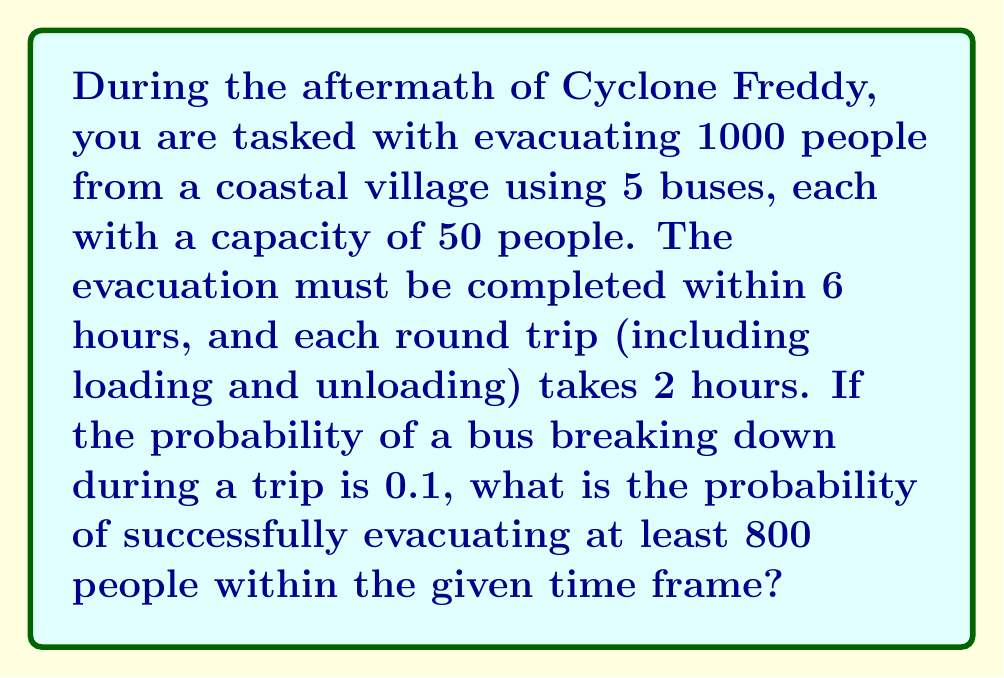Can you answer this question? Let's approach this problem step-by-step:

1) First, calculate the maximum number of trips possible in 6 hours:
   $\text{Maximum trips} = \frac{6 \text{ hours}}{2 \text{ hours per trip}} = 3 \text{ trips}$

2) Calculate the total capacity for all buses over 3 trips:
   $\text{Total capacity} = 5 \text{ buses} \times 50 \text{ people} \times 3 \text{ trips} = 750 \text{ people}$

3) To evacuate at least 800 people, we need all buses to make all 3 trips successfully, plus at least 1 additional trip from any bus.

4) Probability of a bus not breaking down on a single trip: $1 - 0.1 = 0.9$

5) Probability of a bus completing all 3 trips successfully: $0.9^3 = 0.729$

6) Probability of all 5 buses completing all 3 trips successfully:
   $0.729^5 \approx 0.1889$

7) For the additional trip, we need at least one bus to make an extra successful trip. Probability of at least one bus not breaking down:
   $1 - (0.1)^5 = 0.99999$

8) The final probability is the product of steps 6 and 7:
   $P(\text{success}) = 0.1889 \times 0.99999 \approx 0.1889$

Therefore, the probability of successfully evacuating at least 800 people within the given time frame is approximately 0.1889 or 18.89%.
Answer: $0.1889$ 